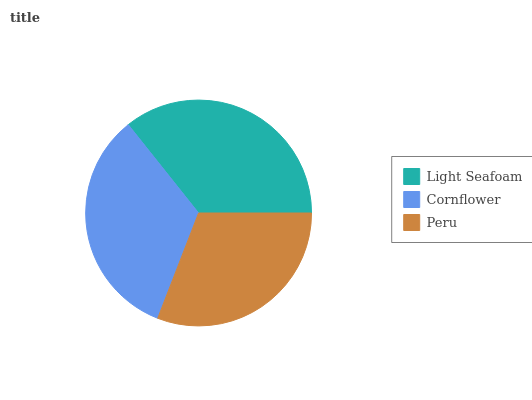Is Peru the minimum?
Answer yes or no. Yes. Is Light Seafoam the maximum?
Answer yes or no. Yes. Is Cornflower the minimum?
Answer yes or no. No. Is Cornflower the maximum?
Answer yes or no. No. Is Light Seafoam greater than Cornflower?
Answer yes or no. Yes. Is Cornflower less than Light Seafoam?
Answer yes or no. Yes. Is Cornflower greater than Light Seafoam?
Answer yes or no. No. Is Light Seafoam less than Cornflower?
Answer yes or no. No. Is Cornflower the high median?
Answer yes or no. Yes. Is Cornflower the low median?
Answer yes or no. Yes. Is Peru the high median?
Answer yes or no. No. Is Peru the low median?
Answer yes or no. No. 